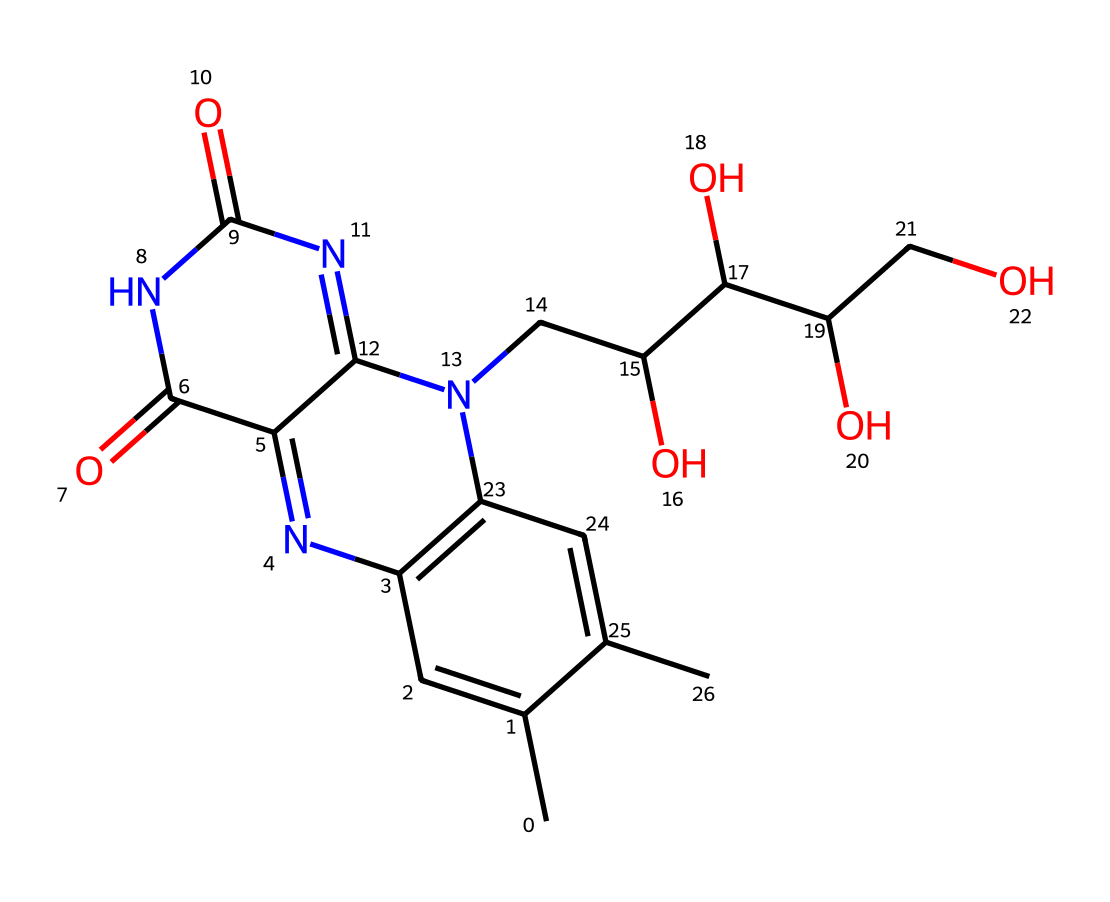What is the molecular formula of riboflavin? The chemical structure provides information about the atoms present, counting carbon (C), hydrogen (H), nitrogen (N), and oxygen (O). In the SMILES representation, there are 17 carbons, 19 hydrogens, 5 nitrogens, and 6 oxygens. Thus, the molecular formula can be derived as C17H19N5O6.
Answer: C17H19N5O6 How many rings are present in the structure of riboflavin? By examining the SMILES representation and the visual structure, we see multiple interconnected cycles. Specifically, there are three distinct ring structures recognized in riboflavin: one pyrimidine ring and two fused heterocyclic rings. This totals three rings.
Answer: 3 What type of bonds connect the atoms in riboflavin? The structure contains various bond types, predominantly sigma (σ) and pi (π) bonds. Analyzing the SMILES detail, we identify carbon-carbon and carbon-nitrogen single bonds giving rise to σ bonds, while the double bonds present indicate π bonds. Thus, riboflavin contains both types of bonds.
Answer: sigma and pi What type of functional groups are present in riboflavin? By reviewing the different parts of the molecule within its SMILES notation, we can identify key functional groups such as hydroxyl (-OH), amine (-NH), and carbonyl (C=O) groups. This information helps identify the compound's roles and properties.
Answer: hydroxyl, amine, carbonyl Which chemical class does riboflavin belong to? Analyzing its structure, riboflavin has several features typical of vitamins, particularly the vitamin B complex. It also exhibits properties of flavonoids due to the presence of the flavin structure. As a result, riboflavin is classified as a water-soluble vitamin.
Answer: vitamin B complex Why is riboflavin considered a photosensitive compound? One can deduce from the presence of conjugated double bonds in the structure that riboflavin can absorb certain light wavelengths, thus making it photosensitive. These conjugated systems are essential for capturing light energy, confirming its role in photosensitivity.
Answer: conjugated double bonds 